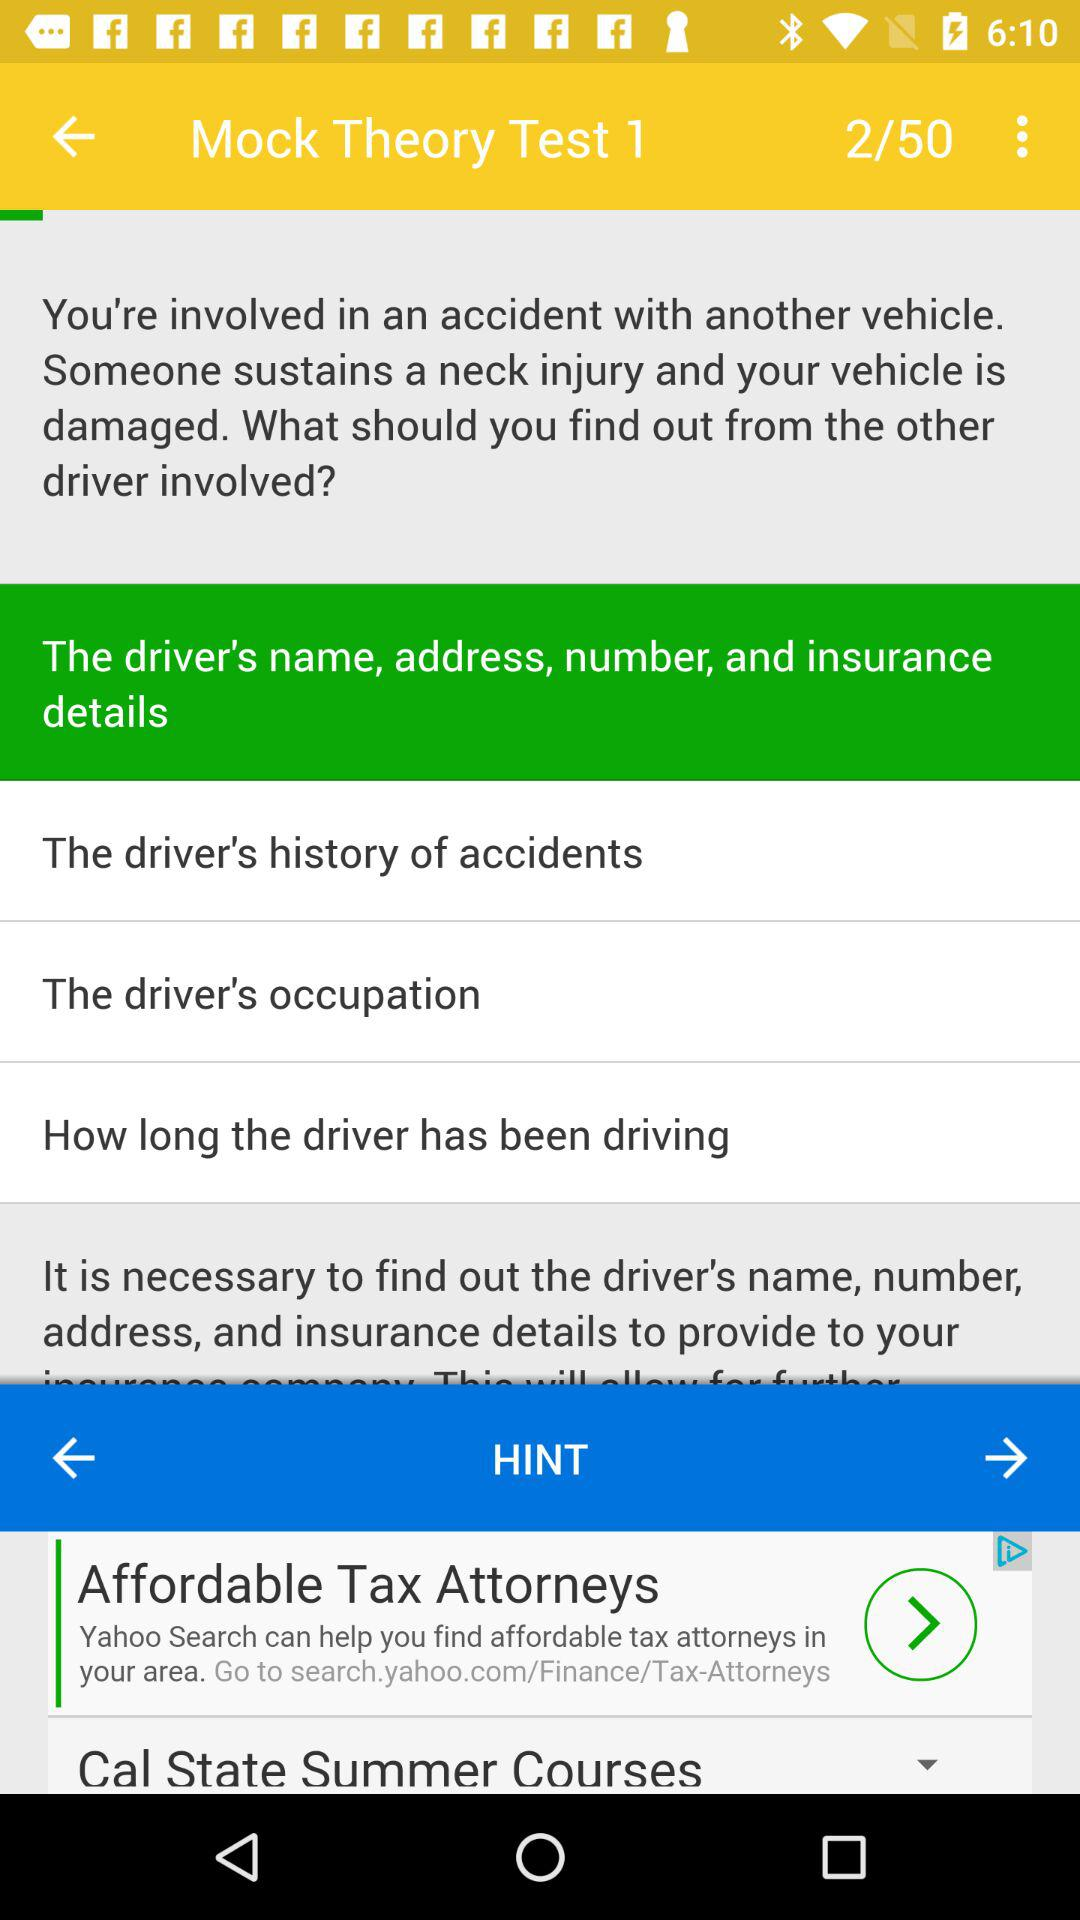Which page is open? The open page is "Mock Theory Test 1". 